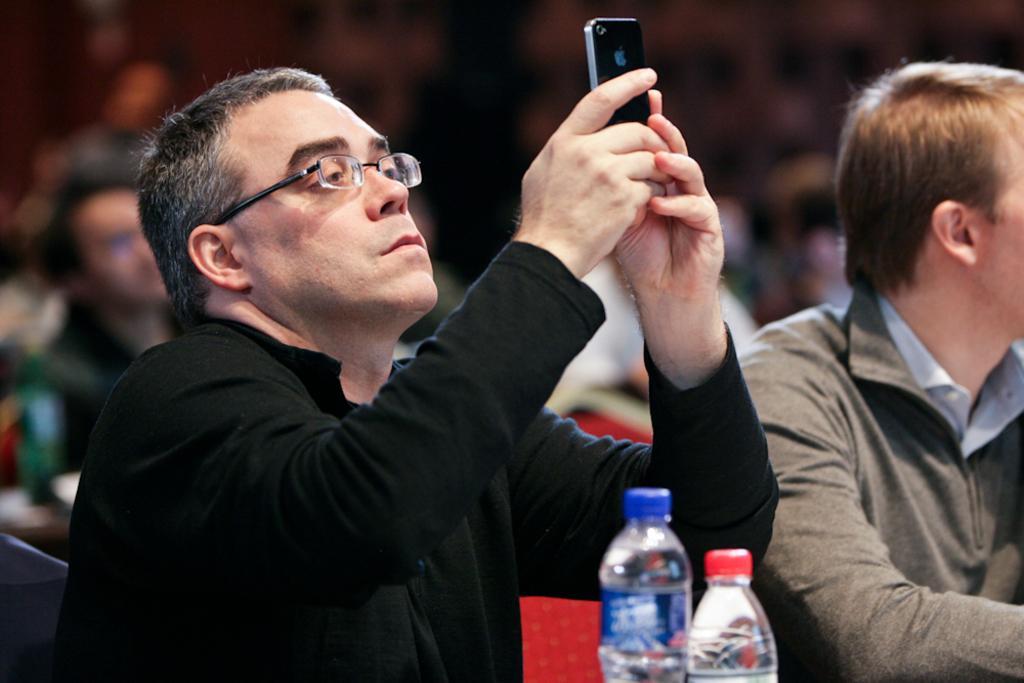Describe this image in one or two sentences. This picture shows a man holding a mobile in his hand and taking a picture and we see other men seated and we see two water bottles and we see few people seated on their back. 